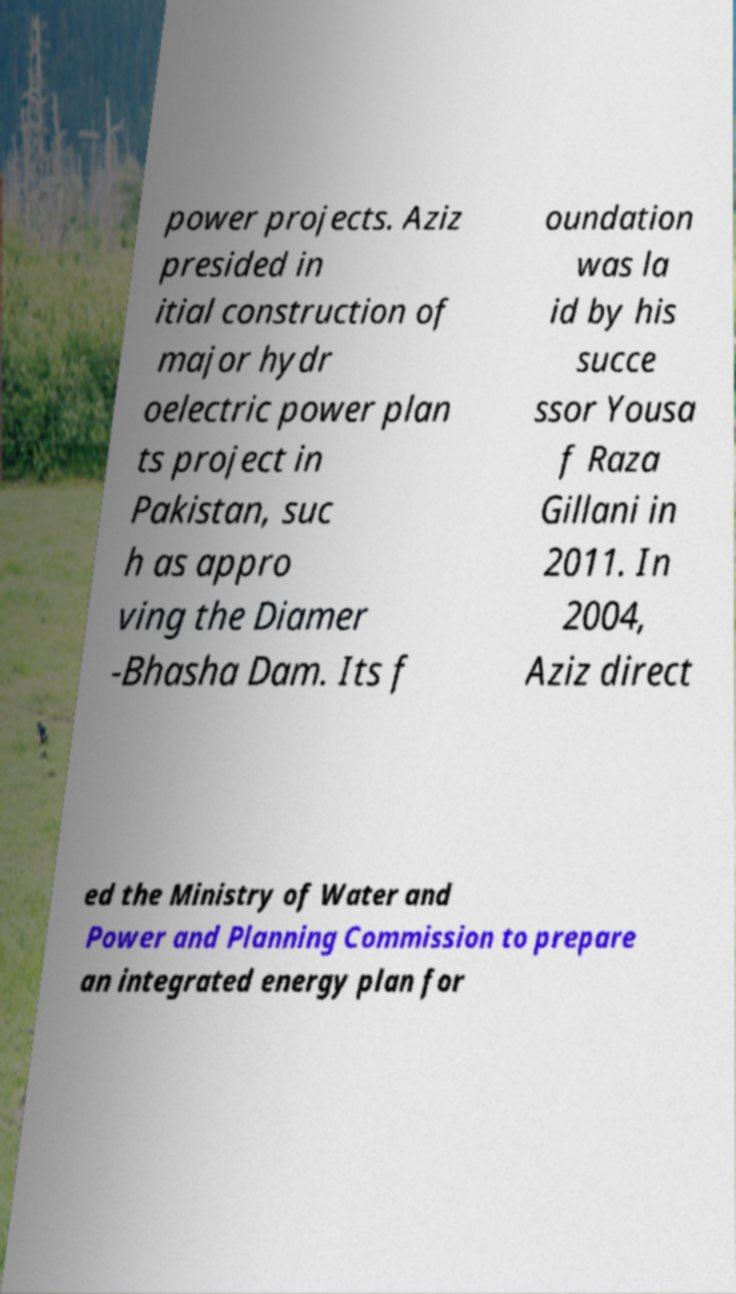For documentation purposes, I need the text within this image transcribed. Could you provide that? power projects. Aziz presided in itial construction of major hydr oelectric power plan ts project in Pakistan, suc h as appro ving the Diamer -Bhasha Dam. Its f oundation was la id by his succe ssor Yousa f Raza Gillani in 2011. In 2004, Aziz direct ed the Ministry of Water and Power and Planning Commission to prepare an integrated energy plan for 